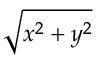Convert formula to latex. <formula><loc_0><loc_0><loc_500><loc_500>\sqrt { x ^ { 2 } + y ^ { 2 } }</formula> 